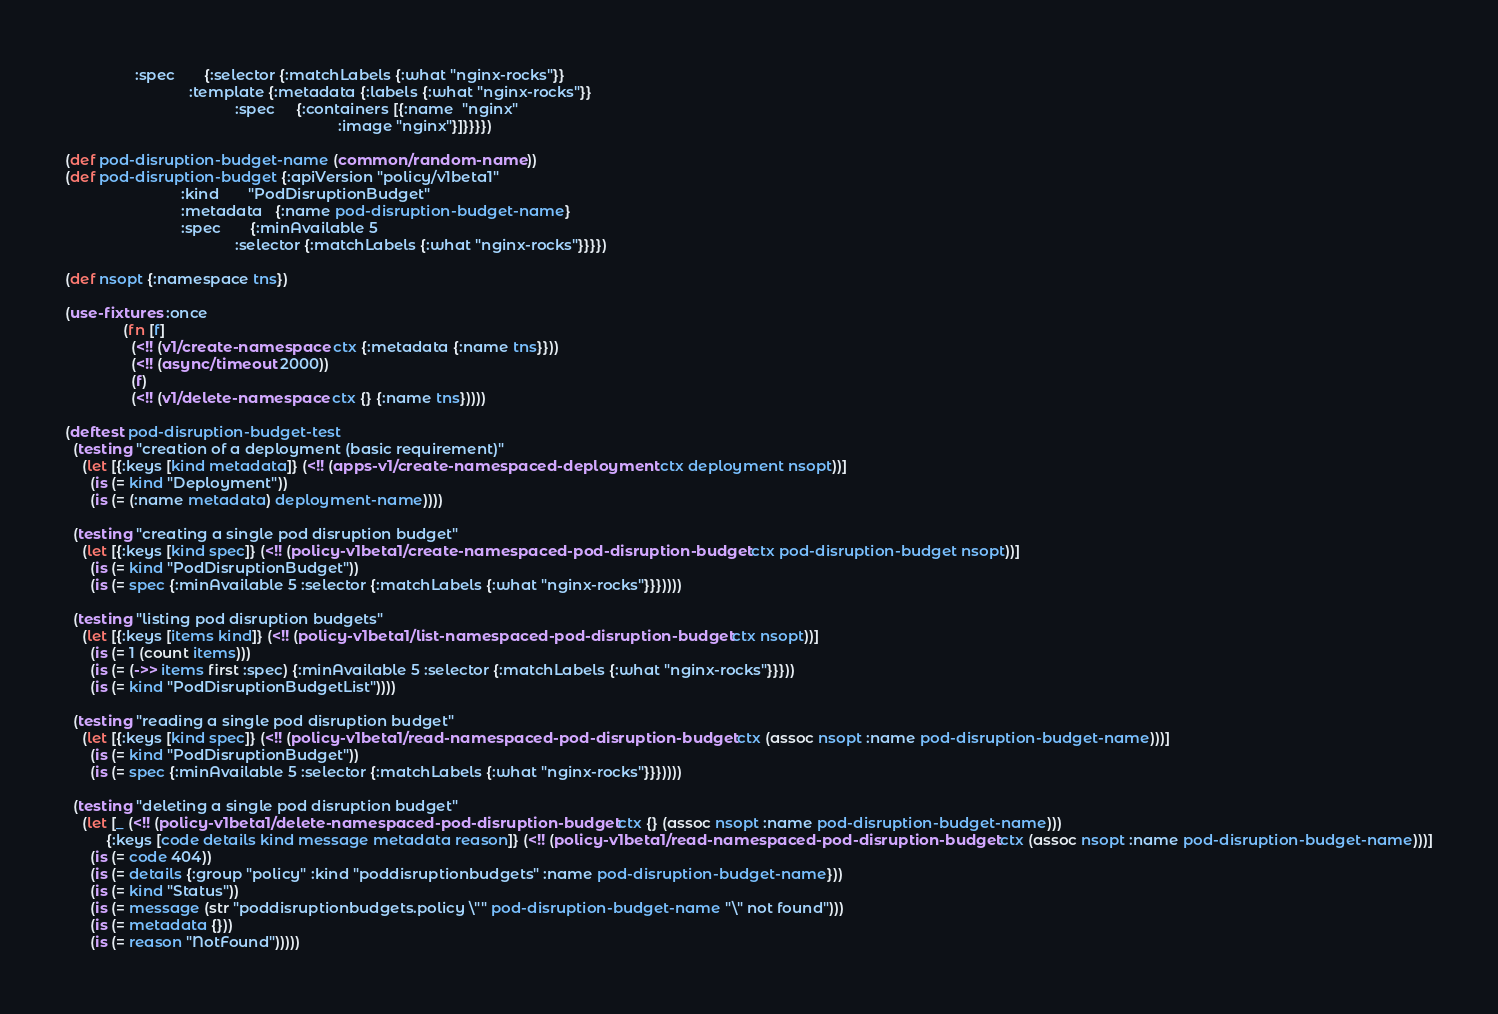Convert code to text. <code><loc_0><loc_0><loc_500><loc_500><_Clojure_>                 :spec       {:selector {:matchLabels {:what "nginx-rocks"}}
                              :template {:metadata {:labels {:what "nginx-rocks"}}
                                         :spec     {:containers [{:name  "nginx"
                                                                  :image "nginx"}]}}}})

(def pod-disruption-budget-name (common/random-name))
(def pod-disruption-budget {:apiVersion "policy/v1beta1"
                            :kind       "PodDisruptionBudget"
                            :metadata   {:name pod-disruption-budget-name}
                            :spec       {:minAvailable 5
                                         :selector {:matchLabels {:what "nginx-rocks"}}}})

(def nsopt {:namespace tns})

(use-fixtures :once
              (fn [f]
                (<!! (v1/create-namespace ctx {:metadata {:name tns}}))
                (<!! (async/timeout 2000))
                (f)
                (<!! (v1/delete-namespace ctx {} {:name tns}))))

(deftest pod-disruption-budget-test
  (testing "creation of a deployment (basic requirement)"
    (let [{:keys [kind metadata]} (<!! (apps-v1/create-namespaced-deployment ctx deployment nsopt))]
      (is (= kind "Deployment"))
      (is (= (:name metadata) deployment-name))))

  (testing "creating a single pod disruption budget"
    (let [{:keys [kind spec]} (<!! (policy-v1beta1/create-namespaced-pod-disruption-budget ctx pod-disruption-budget nsopt))]
      (is (= kind "PodDisruptionBudget"))
      (is (= spec {:minAvailable 5 :selector {:matchLabels {:what "nginx-rocks"}}}))))

  (testing "listing pod disruption budgets"
    (let [{:keys [items kind]} (<!! (policy-v1beta1/list-namespaced-pod-disruption-budget ctx nsopt))]
      (is (= 1 (count items)))
      (is (= (->> items first :spec) {:minAvailable 5 :selector {:matchLabels {:what "nginx-rocks"}}}))
      (is (= kind "PodDisruptionBudgetList"))))

  (testing "reading a single pod disruption budget"
    (let [{:keys [kind spec]} (<!! (policy-v1beta1/read-namespaced-pod-disruption-budget ctx (assoc nsopt :name pod-disruption-budget-name)))]
      (is (= kind "PodDisruptionBudget"))
      (is (= spec {:minAvailable 5 :selector {:matchLabels {:what "nginx-rocks"}}}))))

  (testing "deleting a single pod disruption budget"
    (let [_ (<!! (policy-v1beta1/delete-namespaced-pod-disruption-budget ctx {} (assoc nsopt :name pod-disruption-budget-name)))
          {:keys [code details kind message metadata reason]} (<!! (policy-v1beta1/read-namespaced-pod-disruption-budget ctx (assoc nsopt :name pod-disruption-budget-name)))]
      (is (= code 404))
      (is (= details {:group "policy" :kind "poddisruptionbudgets" :name pod-disruption-budget-name}))
      (is (= kind "Status"))
      (is (= message (str "poddisruptionbudgets.policy \"" pod-disruption-budget-name "\" not found")))
      (is (= metadata {}))
      (is (= reason "NotFound")))))
</code> 